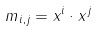<formula> <loc_0><loc_0><loc_500><loc_500>m _ { i , j } = x ^ { i } \cdot x ^ { j }</formula> 